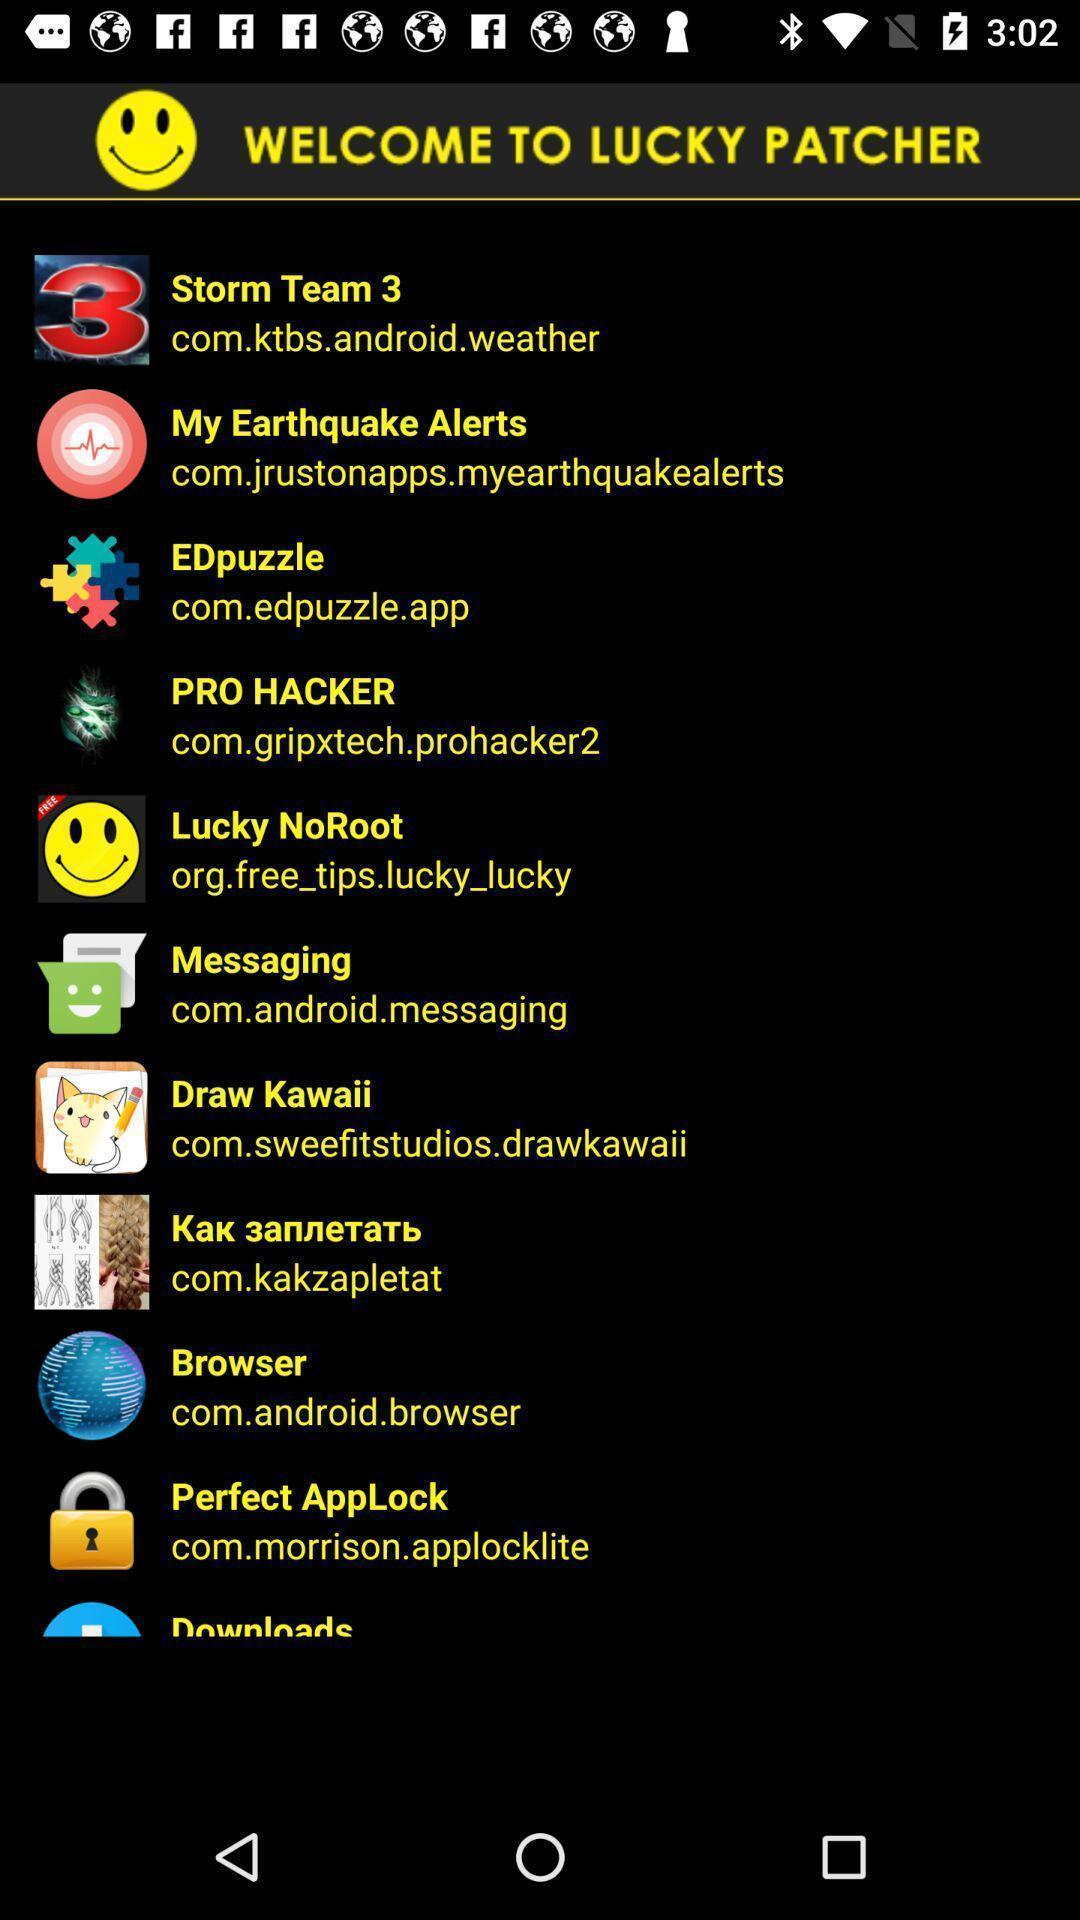Describe the key features of this screenshot. Welcoming page to different types of options. 